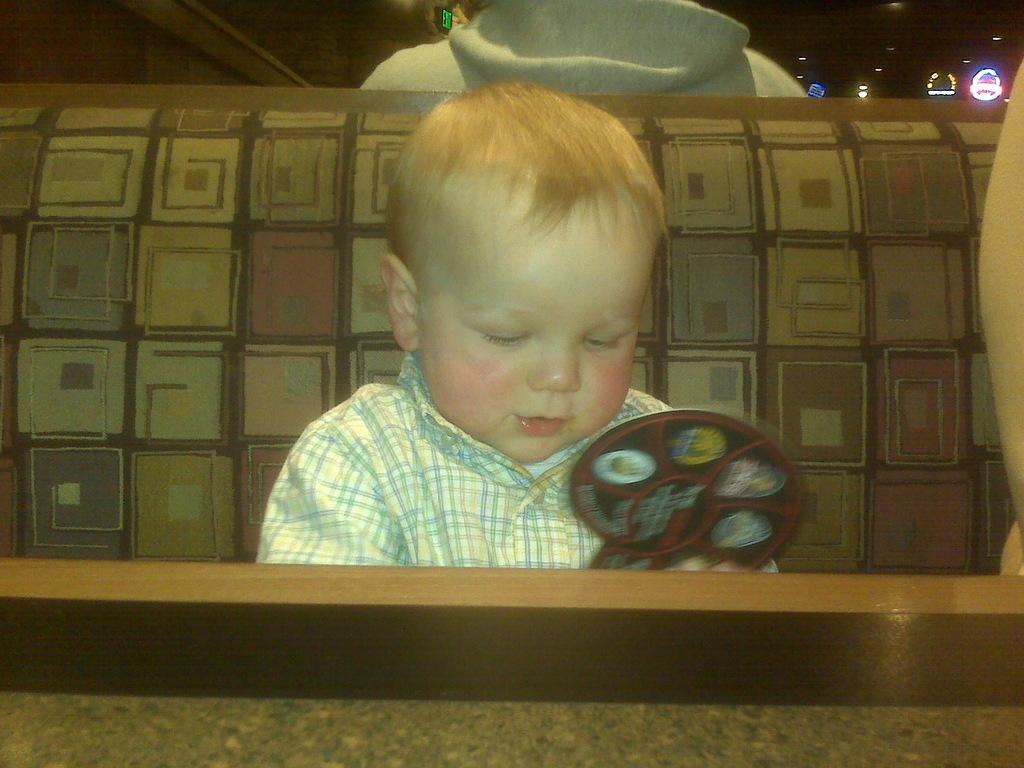What is the main subject of the image? The main subject of the image is a kid. Where is the kid located in the image? The kid is sitting on a sofa in the image. What is the kid doing in the image? The kid is playing with something in the image. What scientific experiment is the kid conducting on their back in the image? There is no scientific experiment or mention of the kid's back in the image. 